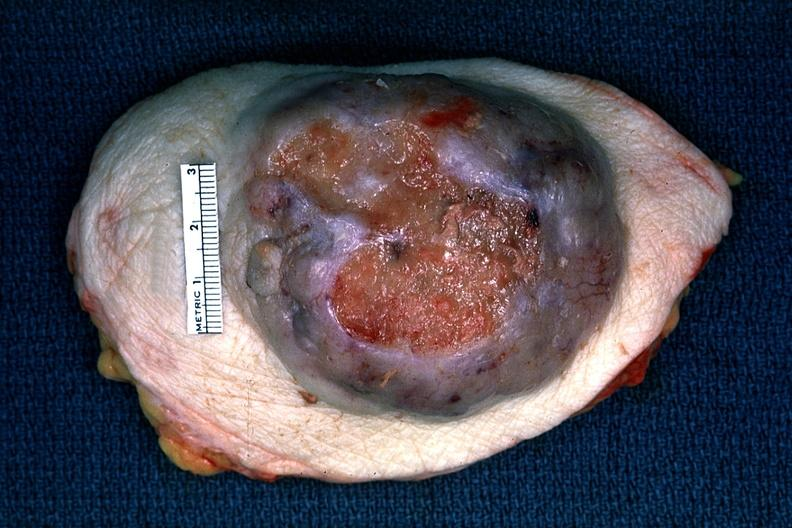what does this image show?
Answer the question using a single word or phrase. Huge ulcerating carcinoma surgical specimen 